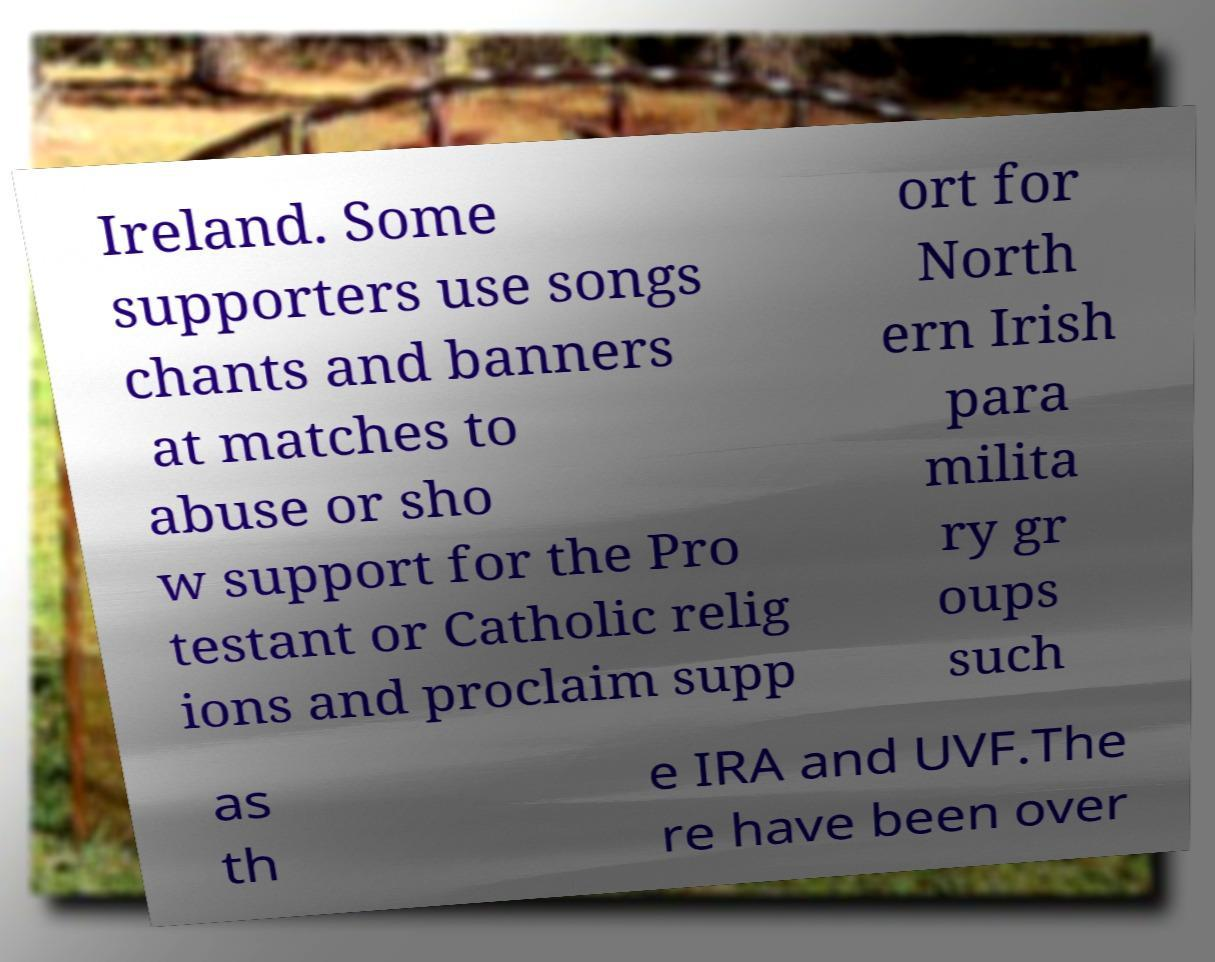Can you accurately transcribe the text from the provided image for me? Ireland. Some supporters use songs chants and banners at matches to abuse or sho w support for the Pro testant or Catholic relig ions and proclaim supp ort for North ern Irish para milita ry gr oups such as th e IRA and UVF.The re have been over 